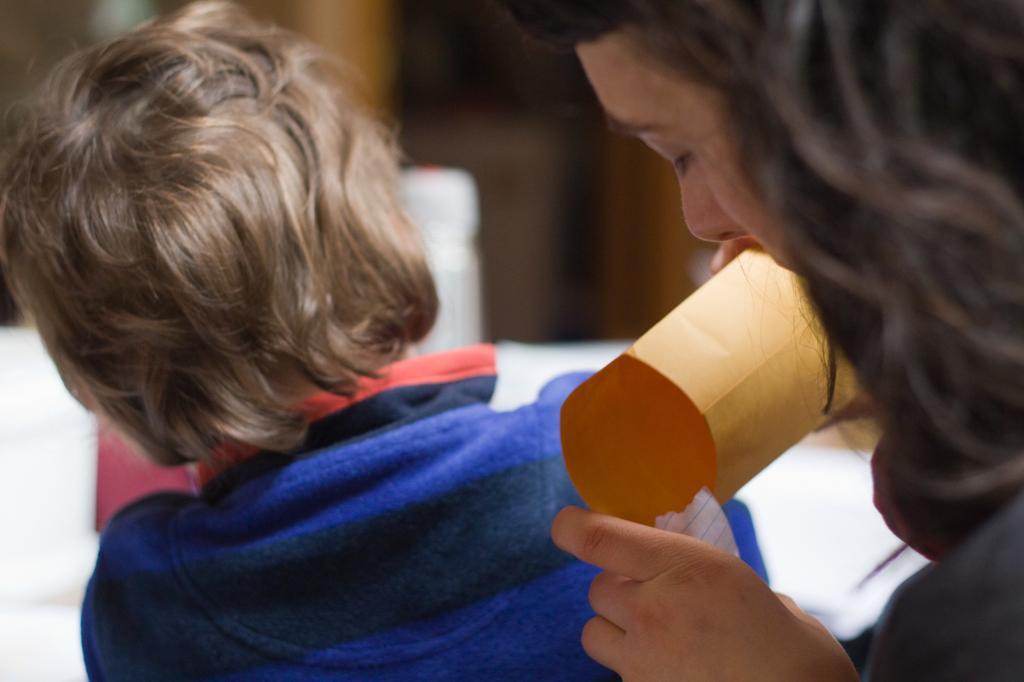In one or two sentences, can you explain what this image depicts? In this picture we can see a woman and a kid in the front, this woman is holding a paper, there is a blurry background. 